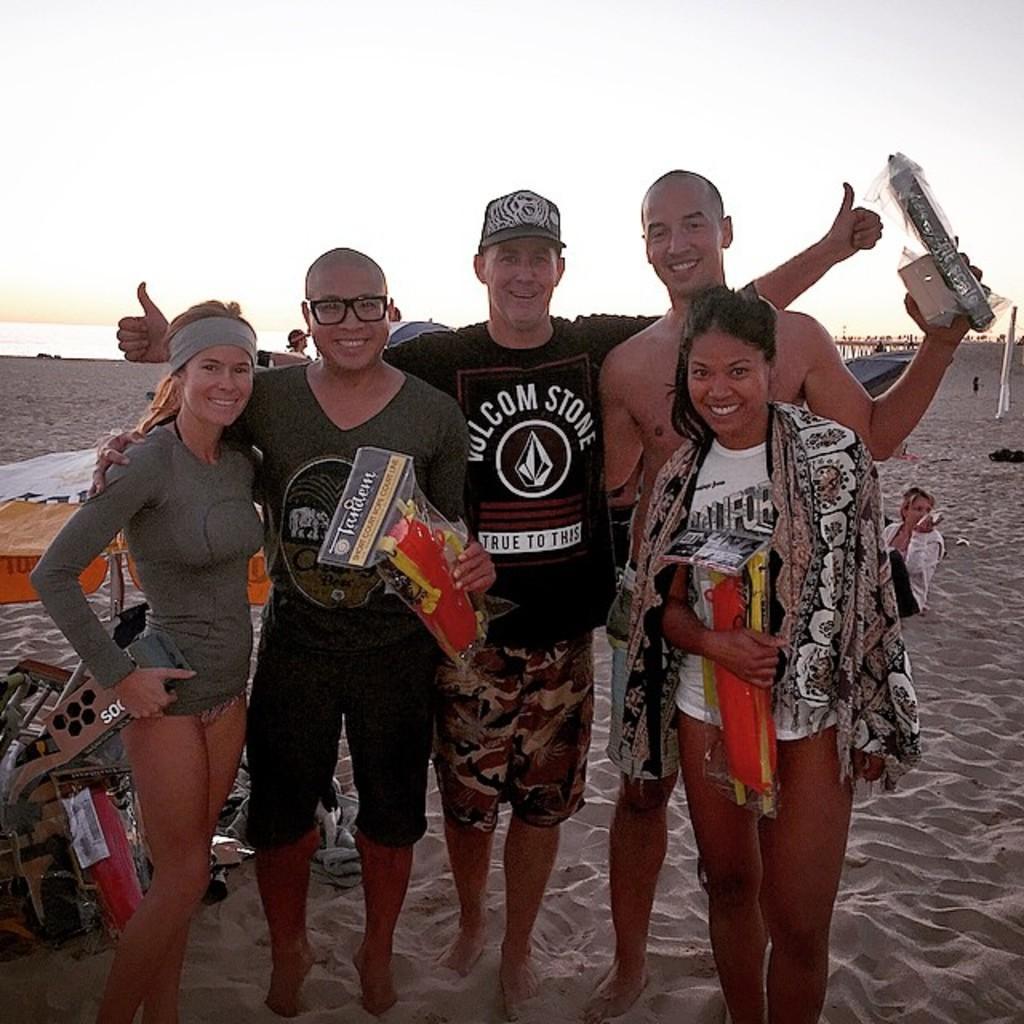Describe this image in one or two sentences. There are five persons in different color dresses, three of them are holding some objects, smiling and standing on the sand surface. Beside them, there is an object. In the background, there is a person and there are clouds in the sky. 